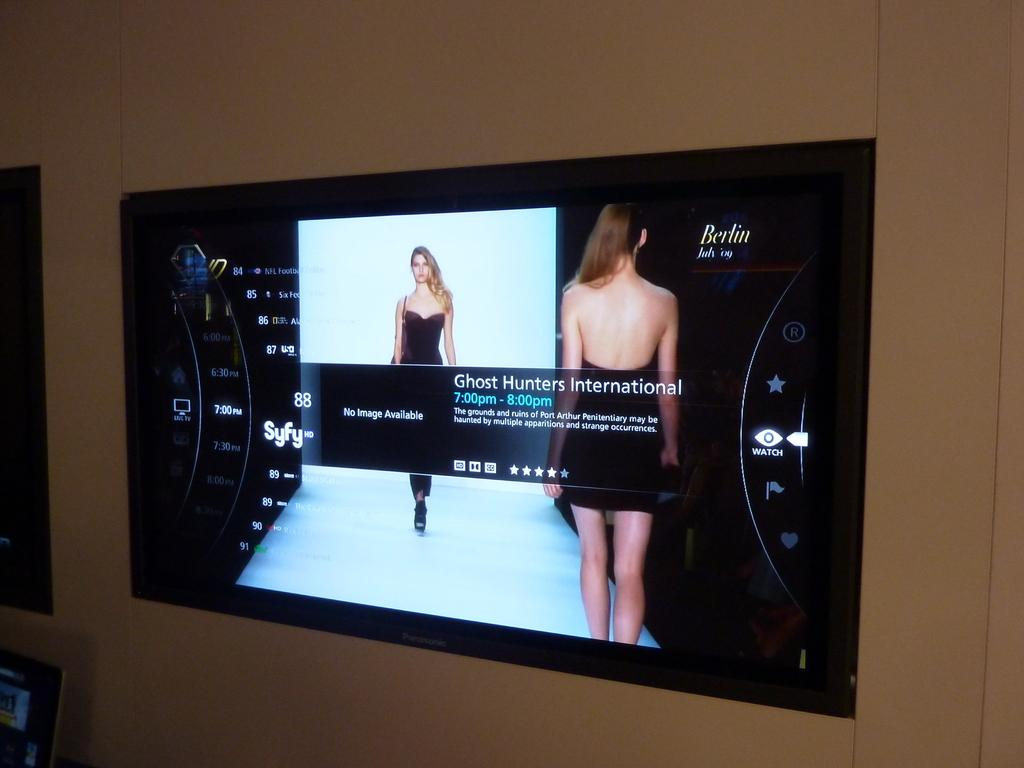<image>
Write a terse but informative summary of the picture. A TV menu displays information for a program called Ghost Hunters International. 